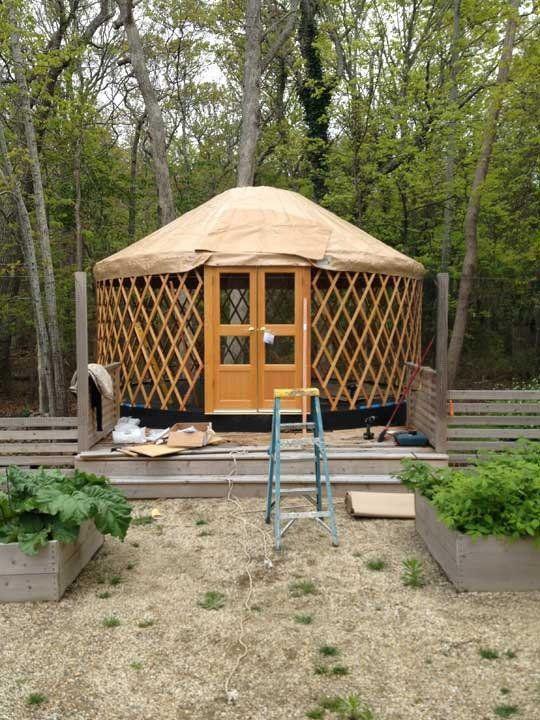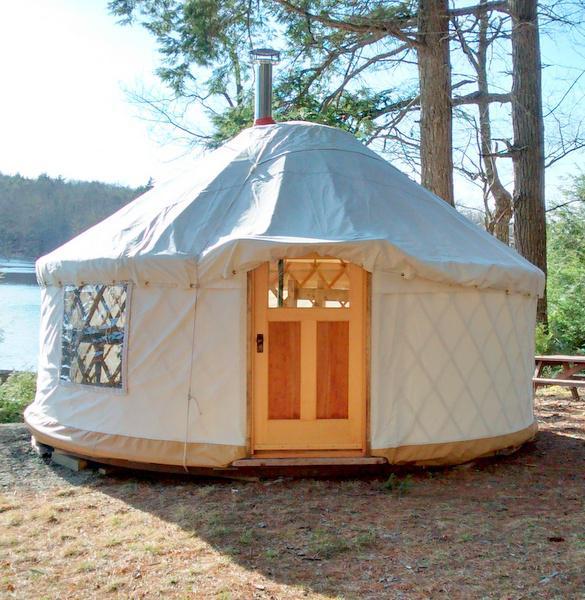The first image is the image on the left, the second image is the image on the right. For the images displayed, is the sentence "There are stairs in the image on the left." factually correct? Answer yes or no. Yes. The first image is the image on the left, the second image is the image on the right. Assess this claim about the two images: "A white round house has a forward facing door and at least one window.". Correct or not? Answer yes or no. Yes. 